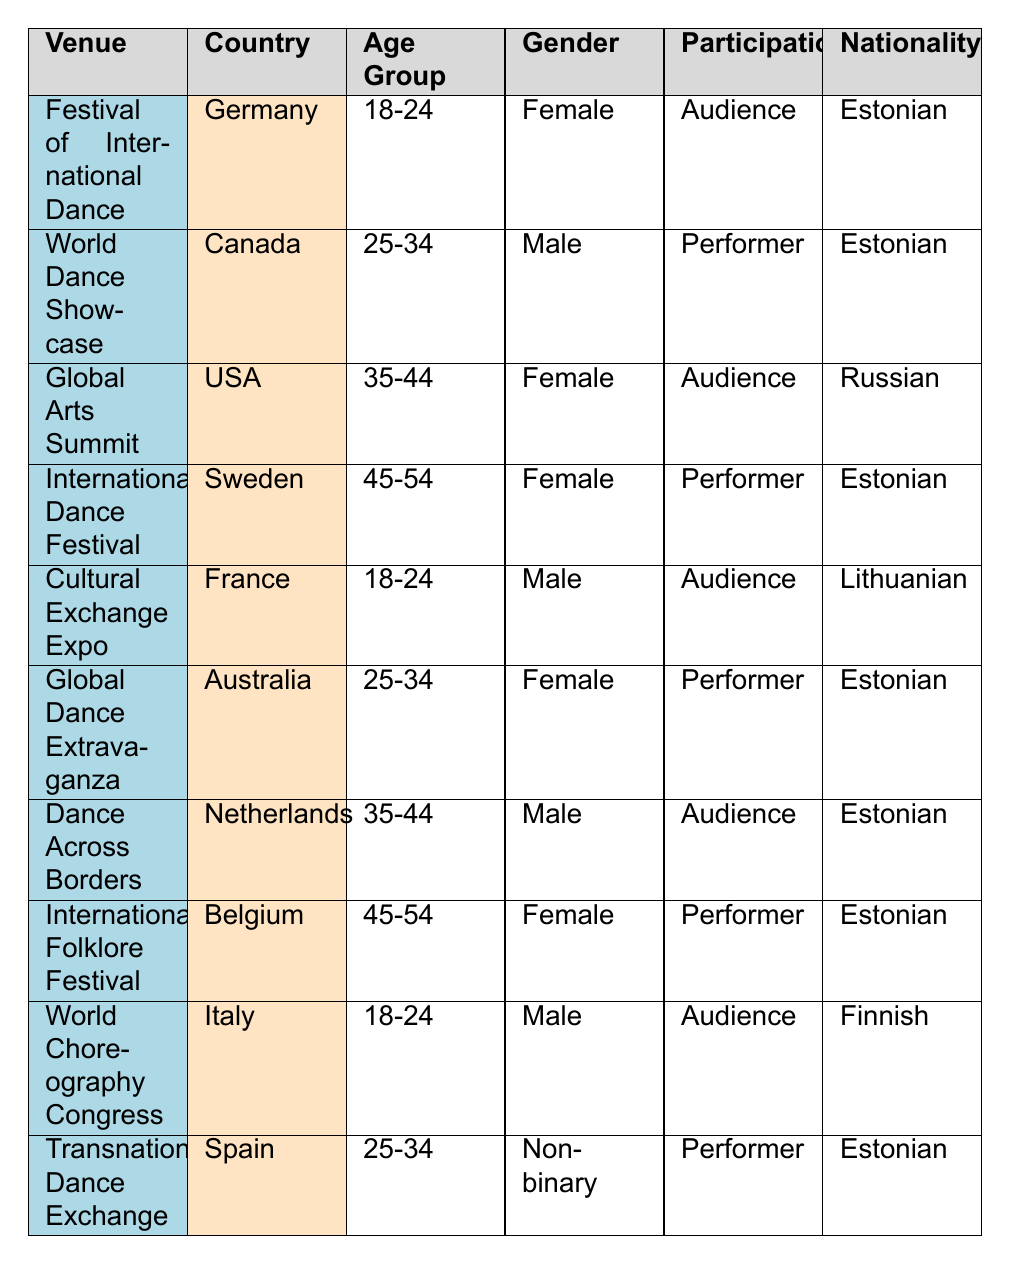What is the nationality of the participants who performed at the International Dance Festival? The International Dance Festival has one entry for a performer, who is noted as being of Estonian nationality. Therefore, the nationality of the participant who performed there is Estonian.
Answer: Estonian How many performers are listed as being from Estonia? By counting the rows in the table, the entries that list "Estonian" in the nationality column correspond to performers that are as follows: World Dance Showcase, International Dance Festival, Global Dance Extravaganza, International Folklore Festival, and Transnational Dance Exchange. There are four performers from Estonia: 1) World Dance Showcase, 2) International Dance Festival, 3) Global Dance Extravaganza, and 4) International Folklore Festival.
Answer: 4 Is there any male audience from Estonia in this table? The only male listed as being from Estonia in an audience type is found under the Festival of International Dance. Therefore, the answer is yes.
Answer: Yes What is the age group of the majority of Estonian participants in the table? The Estonian participants include ages 18-24 (1), 25-34 (2), 45-54 (2) with one additional member aged 35-44 and determines this demographic as split of 5 older participants in 25-34 and 45-54 category and only one younger 18-24 participant. The groups 25-34 and 45-54 both have the same number of representatives, thus we cannot declare one group as the majority since there’s a tie.
Answer: No majority How many venues are represented in the table? From the table provided, we can list the venues: Festival of International Dance, World Dance Showcase, Global Arts Summit, International Dance Festival, Cultural Exchange Expo, Global Dance Extravaganza, Dance Across Borders, International Folklore Festival, World Choreography Congress, and Transnational Dance Exchange. Each venue is unique, totaling 10 venues represented.
Answer: 10 Are there any non-binary participants in the table? According to the table, there is one entry under Transnational Dance Exchange for a non-binary individual who is categorized as a performer, confirming the presence of a non-binary participant within the data.
Answer: Yes What is the ratio of female performers to male performers among Estonian participants? The table entries show that there are 3 female performers (World Dance Showcase, International Dance Festival, International Folklore Festival) and 1 male performer (World Dance Showcase) among the Estonian nationality participants. Thus, the ratio of female performers to male performers is 3:1.
Answer: 3:1 How many participants aged 35-44 are there in total across all nationalities? Looking specifically at the age group of 35-44, the entries show two participants: one male from Dance Across Borders (Estonian) and another female from Global Arts Summit (Russian). Totaling these gives us 2 participants aged 35-44 across all nationalities.
Answer: 2 What is the nationality of the only non-binary participant? The Transnational Dance Exchange lists the only non-binary participant in the table, and their nationality is recorded as Estonian. Therefore, the nationality of the non-binary participant is Estonian.
Answer: Estonian 